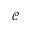<formula> <loc_0><loc_0><loc_500><loc_500>\mathcal { C }</formula> 